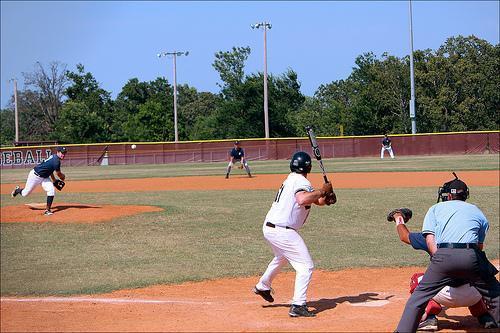How many bats are there?
Give a very brief answer. 1. 